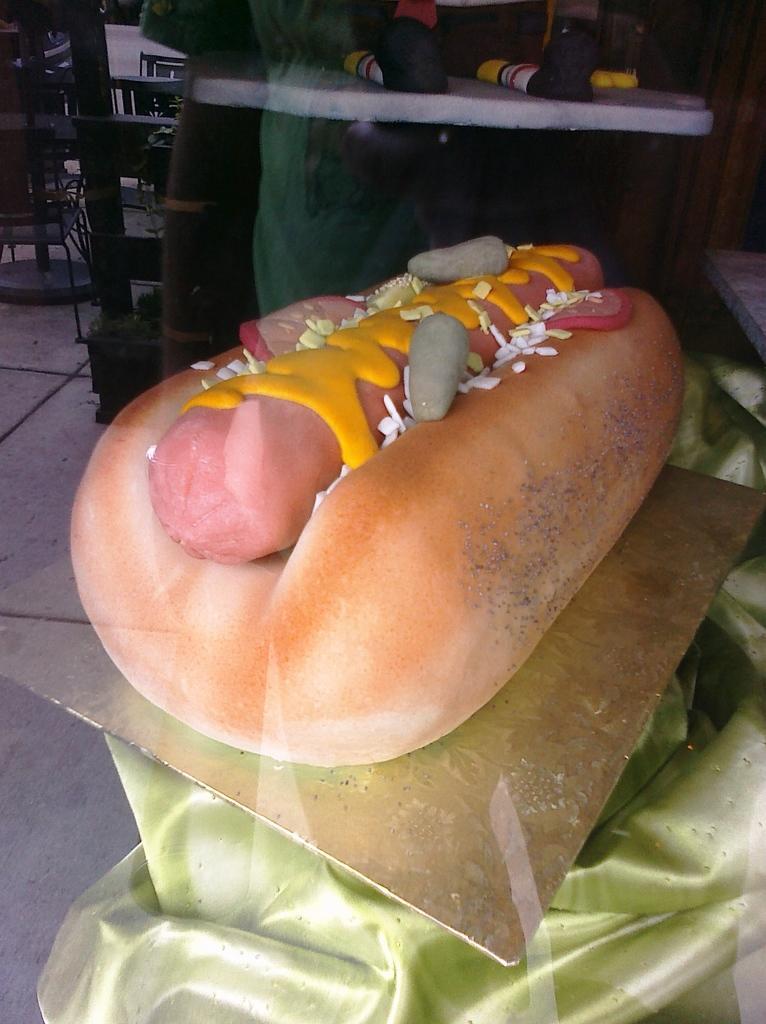Please provide a concise description of this image. In this picture I can see the burger which is kept on this steel plate. At the top there is a woman who is standing near to the table. On the table I can see some clothes. In the background I can see the leaders and poles. At the bottom there is a cloth. 